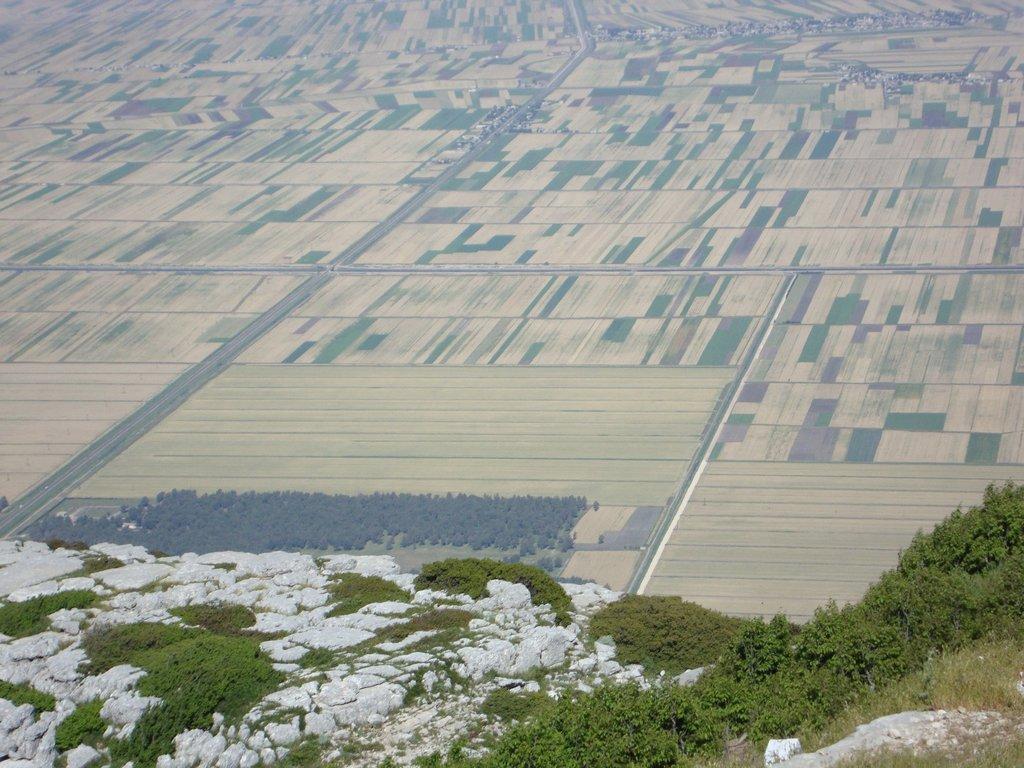How would you summarize this image in a sentence or two? In this image I can see few plants and some grass on the mountain. In the background I can see the ground, few trees and the road. 